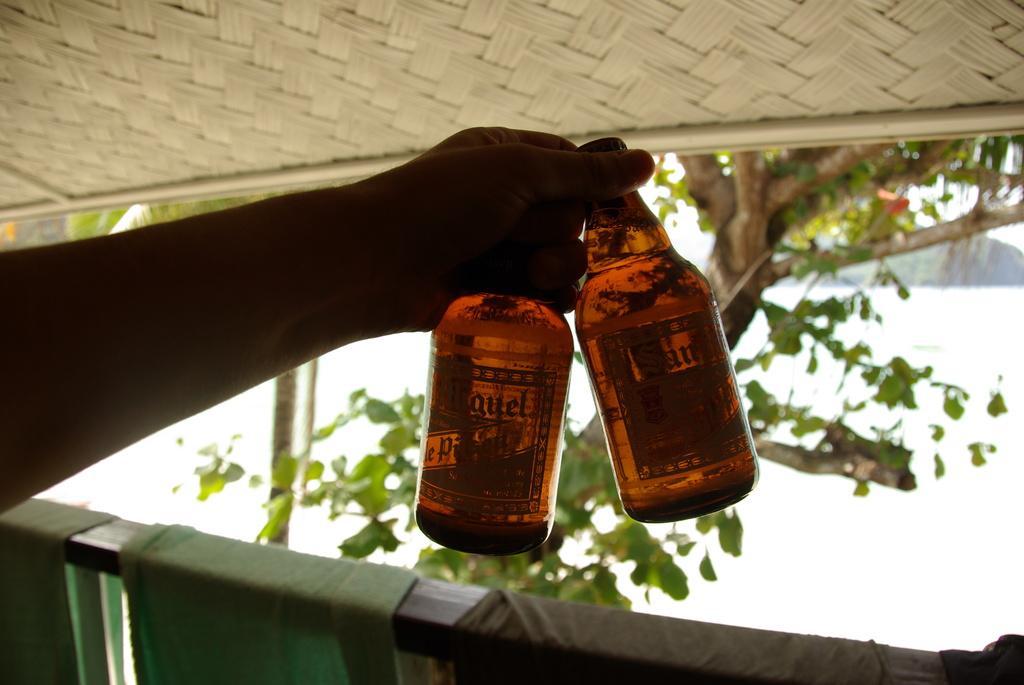Please provide a concise description of this image. In this image i can see a person's hand who is holding two bottles at the background of the image. 